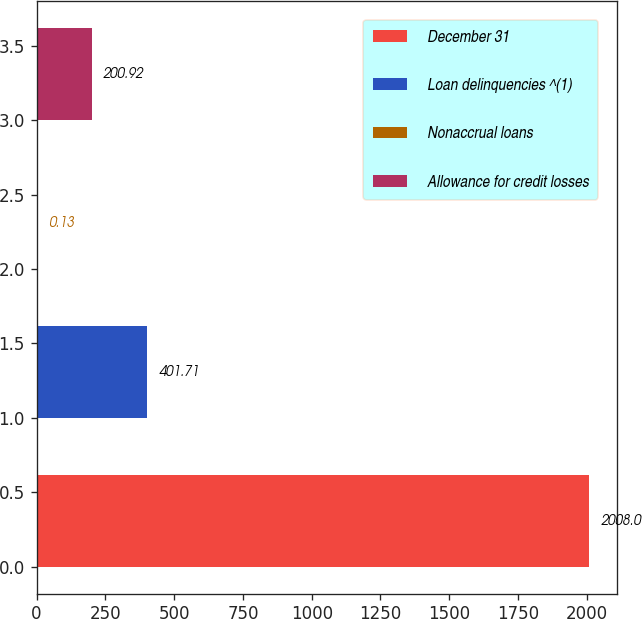Convert chart to OTSL. <chart><loc_0><loc_0><loc_500><loc_500><bar_chart><fcel>December 31<fcel>Loan delinquencies ^(1)<fcel>Nonaccrual loans<fcel>Allowance for credit losses<nl><fcel>2008<fcel>401.71<fcel>0.13<fcel>200.92<nl></chart> 